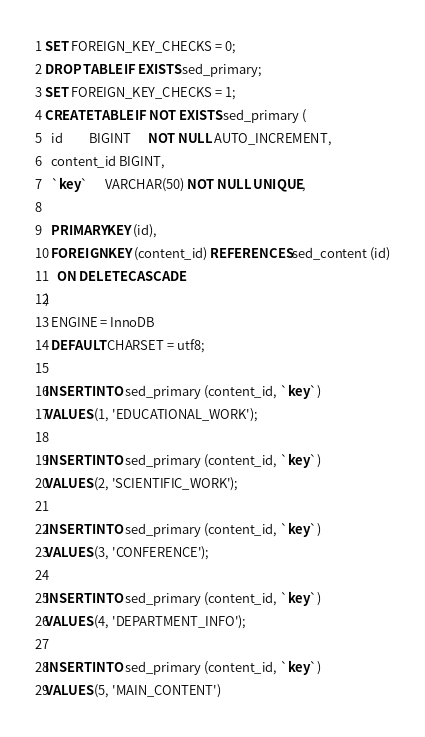<code> <loc_0><loc_0><loc_500><loc_500><_SQL_>SET FOREIGN_KEY_CHECKS = 0;
DROP TABLE IF EXISTS sed_primary;
SET FOREIGN_KEY_CHECKS = 1;
CREATE TABLE IF NOT EXISTS sed_primary (
  id         BIGINT      NOT NULL AUTO_INCREMENT,
  content_id BIGINT,
  `key`      VARCHAR(50) NOT NULL UNIQUE,

  PRIMARY KEY (id),
  FOREIGN KEY (content_id) REFERENCES sed_content (id)
    ON DELETE CASCADE
)
  ENGINE = InnoDB
  DEFAULT CHARSET = utf8;

INSERT INTO sed_primary (content_id, `key`)
VALUES (1, 'EDUCATIONAL_WORK');

INSERT INTO sed_primary (content_id, `key`)
VALUES (2, 'SCIENTIFIC_WORK');

INSERT INTO sed_primary (content_id, `key`)
VALUES (3, 'CONFERENCE');

INSERT INTO sed_primary (content_id, `key`)
VALUES (4, 'DEPARTMENT_INFO');

INSERT INTO sed_primary (content_id, `key`)
VALUES (5, 'MAIN_CONTENT')
</code> 